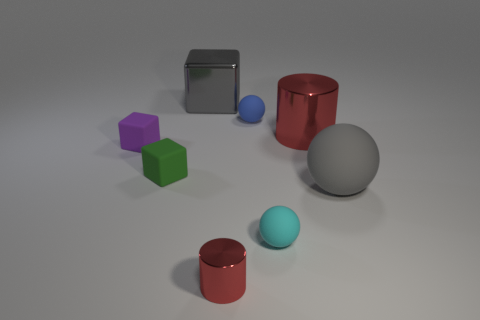How many other things are the same color as the large rubber thing?
Offer a very short reply. 1. There is a gray thing in front of the big red metallic object; does it have the same shape as the red shiny object behind the tiny green rubber thing?
Your answer should be very brief. No. What shape is the red metallic thing that is the same size as the blue sphere?
Offer a terse response. Cylinder. Is the number of tiny purple matte objects that are behind the big red shiny cylinder the same as the number of cyan spheres on the left side of the tiny cyan sphere?
Offer a very short reply. Yes. Do the big red thing that is behind the green block and the green object have the same material?
Give a very brief answer. No. There is a purple cube that is the same size as the green cube; what is its material?
Provide a succinct answer. Rubber. How many other objects are the same material as the small purple object?
Your answer should be very brief. 4. Do the gray block and the sphere that is behind the large gray sphere have the same size?
Ensure brevity in your answer.  No. Are there fewer tiny blue rubber spheres that are left of the small green matte cube than tiny cyan balls that are in front of the metal cube?
Give a very brief answer. Yes. What is the size of the gray thing that is in front of the large gray metallic cube?
Offer a very short reply. Large. 